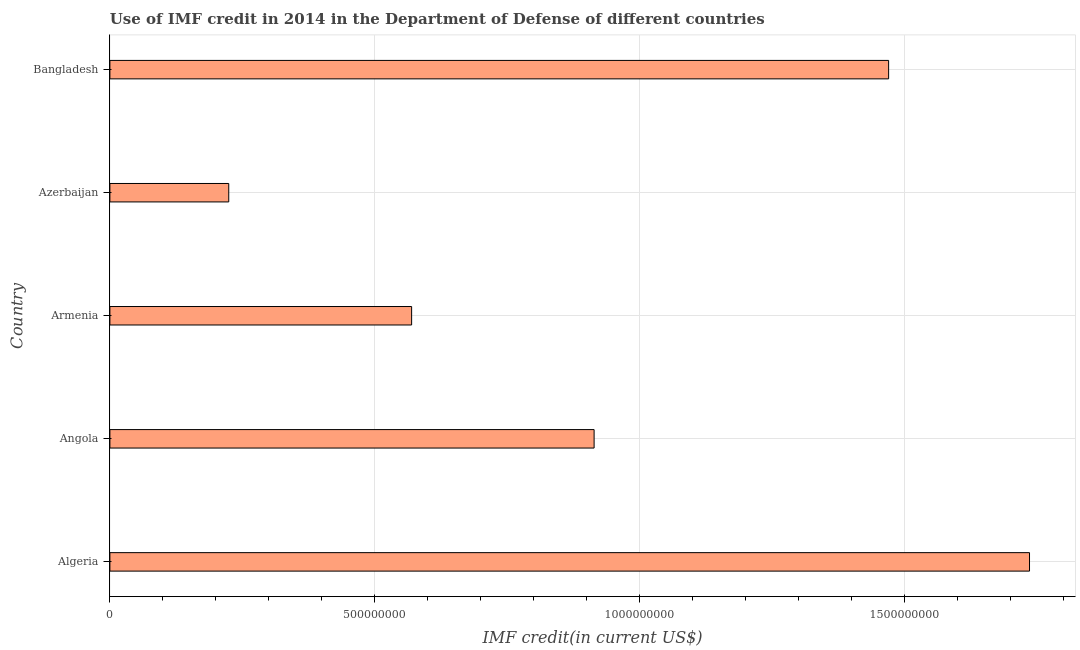What is the title of the graph?
Ensure brevity in your answer.  Use of IMF credit in 2014 in the Department of Defense of different countries. What is the label or title of the X-axis?
Your answer should be very brief. IMF credit(in current US$). What is the label or title of the Y-axis?
Your response must be concise. Country. What is the use of imf credit in dod in Angola?
Keep it short and to the point. 9.14e+08. Across all countries, what is the maximum use of imf credit in dod?
Offer a very short reply. 1.74e+09. Across all countries, what is the minimum use of imf credit in dod?
Offer a very short reply. 2.24e+08. In which country was the use of imf credit in dod maximum?
Your answer should be very brief. Algeria. In which country was the use of imf credit in dod minimum?
Keep it short and to the point. Azerbaijan. What is the sum of the use of imf credit in dod?
Ensure brevity in your answer.  4.91e+09. What is the difference between the use of imf credit in dod in Angola and Bangladesh?
Your response must be concise. -5.56e+08. What is the average use of imf credit in dod per country?
Keep it short and to the point. 9.83e+08. What is the median use of imf credit in dod?
Your answer should be compact. 9.14e+08. In how many countries, is the use of imf credit in dod greater than 1600000000 US$?
Your response must be concise. 1. What is the ratio of the use of imf credit in dod in Armenia to that in Bangladesh?
Offer a very short reply. 0.39. What is the difference between the highest and the second highest use of imf credit in dod?
Offer a very short reply. 2.66e+08. Is the sum of the use of imf credit in dod in Armenia and Bangladesh greater than the maximum use of imf credit in dod across all countries?
Provide a succinct answer. Yes. What is the difference between the highest and the lowest use of imf credit in dod?
Offer a terse response. 1.51e+09. In how many countries, is the use of imf credit in dod greater than the average use of imf credit in dod taken over all countries?
Offer a terse response. 2. How many bars are there?
Your response must be concise. 5. Are all the bars in the graph horizontal?
Your response must be concise. Yes. What is the IMF credit(in current US$) of Algeria?
Offer a very short reply. 1.74e+09. What is the IMF credit(in current US$) in Angola?
Offer a very short reply. 9.14e+08. What is the IMF credit(in current US$) of Armenia?
Keep it short and to the point. 5.70e+08. What is the IMF credit(in current US$) in Azerbaijan?
Keep it short and to the point. 2.24e+08. What is the IMF credit(in current US$) of Bangladesh?
Offer a very short reply. 1.47e+09. What is the difference between the IMF credit(in current US$) in Algeria and Angola?
Ensure brevity in your answer.  8.22e+08. What is the difference between the IMF credit(in current US$) in Algeria and Armenia?
Offer a very short reply. 1.17e+09. What is the difference between the IMF credit(in current US$) in Algeria and Azerbaijan?
Provide a short and direct response. 1.51e+09. What is the difference between the IMF credit(in current US$) in Algeria and Bangladesh?
Keep it short and to the point. 2.66e+08. What is the difference between the IMF credit(in current US$) in Angola and Armenia?
Provide a short and direct response. 3.44e+08. What is the difference between the IMF credit(in current US$) in Angola and Azerbaijan?
Keep it short and to the point. 6.90e+08. What is the difference between the IMF credit(in current US$) in Angola and Bangladesh?
Keep it short and to the point. -5.56e+08. What is the difference between the IMF credit(in current US$) in Armenia and Azerbaijan?
Your answer should be compact. 3.45e+08. What is the difference between the IMF credit(in current US$) in Armenia and Bangladesh?
Give a very brief answer. -9.00e+08. What is the difference between the IMF credit(in current US$) in Azerbaijan and Bangladesh?
Give a very brief answer. -1.25e+09. What is the ratio of the IMF credit(in current US$) in Algeria to that in Angola?
Make the answer very short. 1.9. What is the ratio of the IMF credit(in current US$) in Algeria to that in Armenia?
Make the answer very short. 3.05. What is the ratio of the IMF credit(in current US$) in Algeria to that in Azerbaijan?
Your response must be concise. 7.74. What is the ratio of the IMF credit(in current US$) in Algeria to that in Bangladesh?
Your answer should be very brief. 1.18. What is the ratio of the IMF credit(in current US$) in Angola to that in Armenia?
Your answer should be very brief. 1.6. What is the ratio of the IMF credit(in current US$) in Angola to that in Azerbaijan?
Keep it short and to the point. 4.07. What is the ratio of the IMF credit(in current US$) in Angola to that in Bangladesh?
Provide a short and direct response. 0.62. What is the ratio of the IMF credit(in current US$) in Armenia to that in Azerbaijan?
Give a very brief answer. 2.54. What is the ratio of the IMF credit(in current US$) in Armenia to that in Bangladesh?
Offer a terse response. 0.39. What is the ratio of the IMF credit(in current US$) in Azerbaijan to that in Bangladesh?
Offer a terse response. 0.15. 